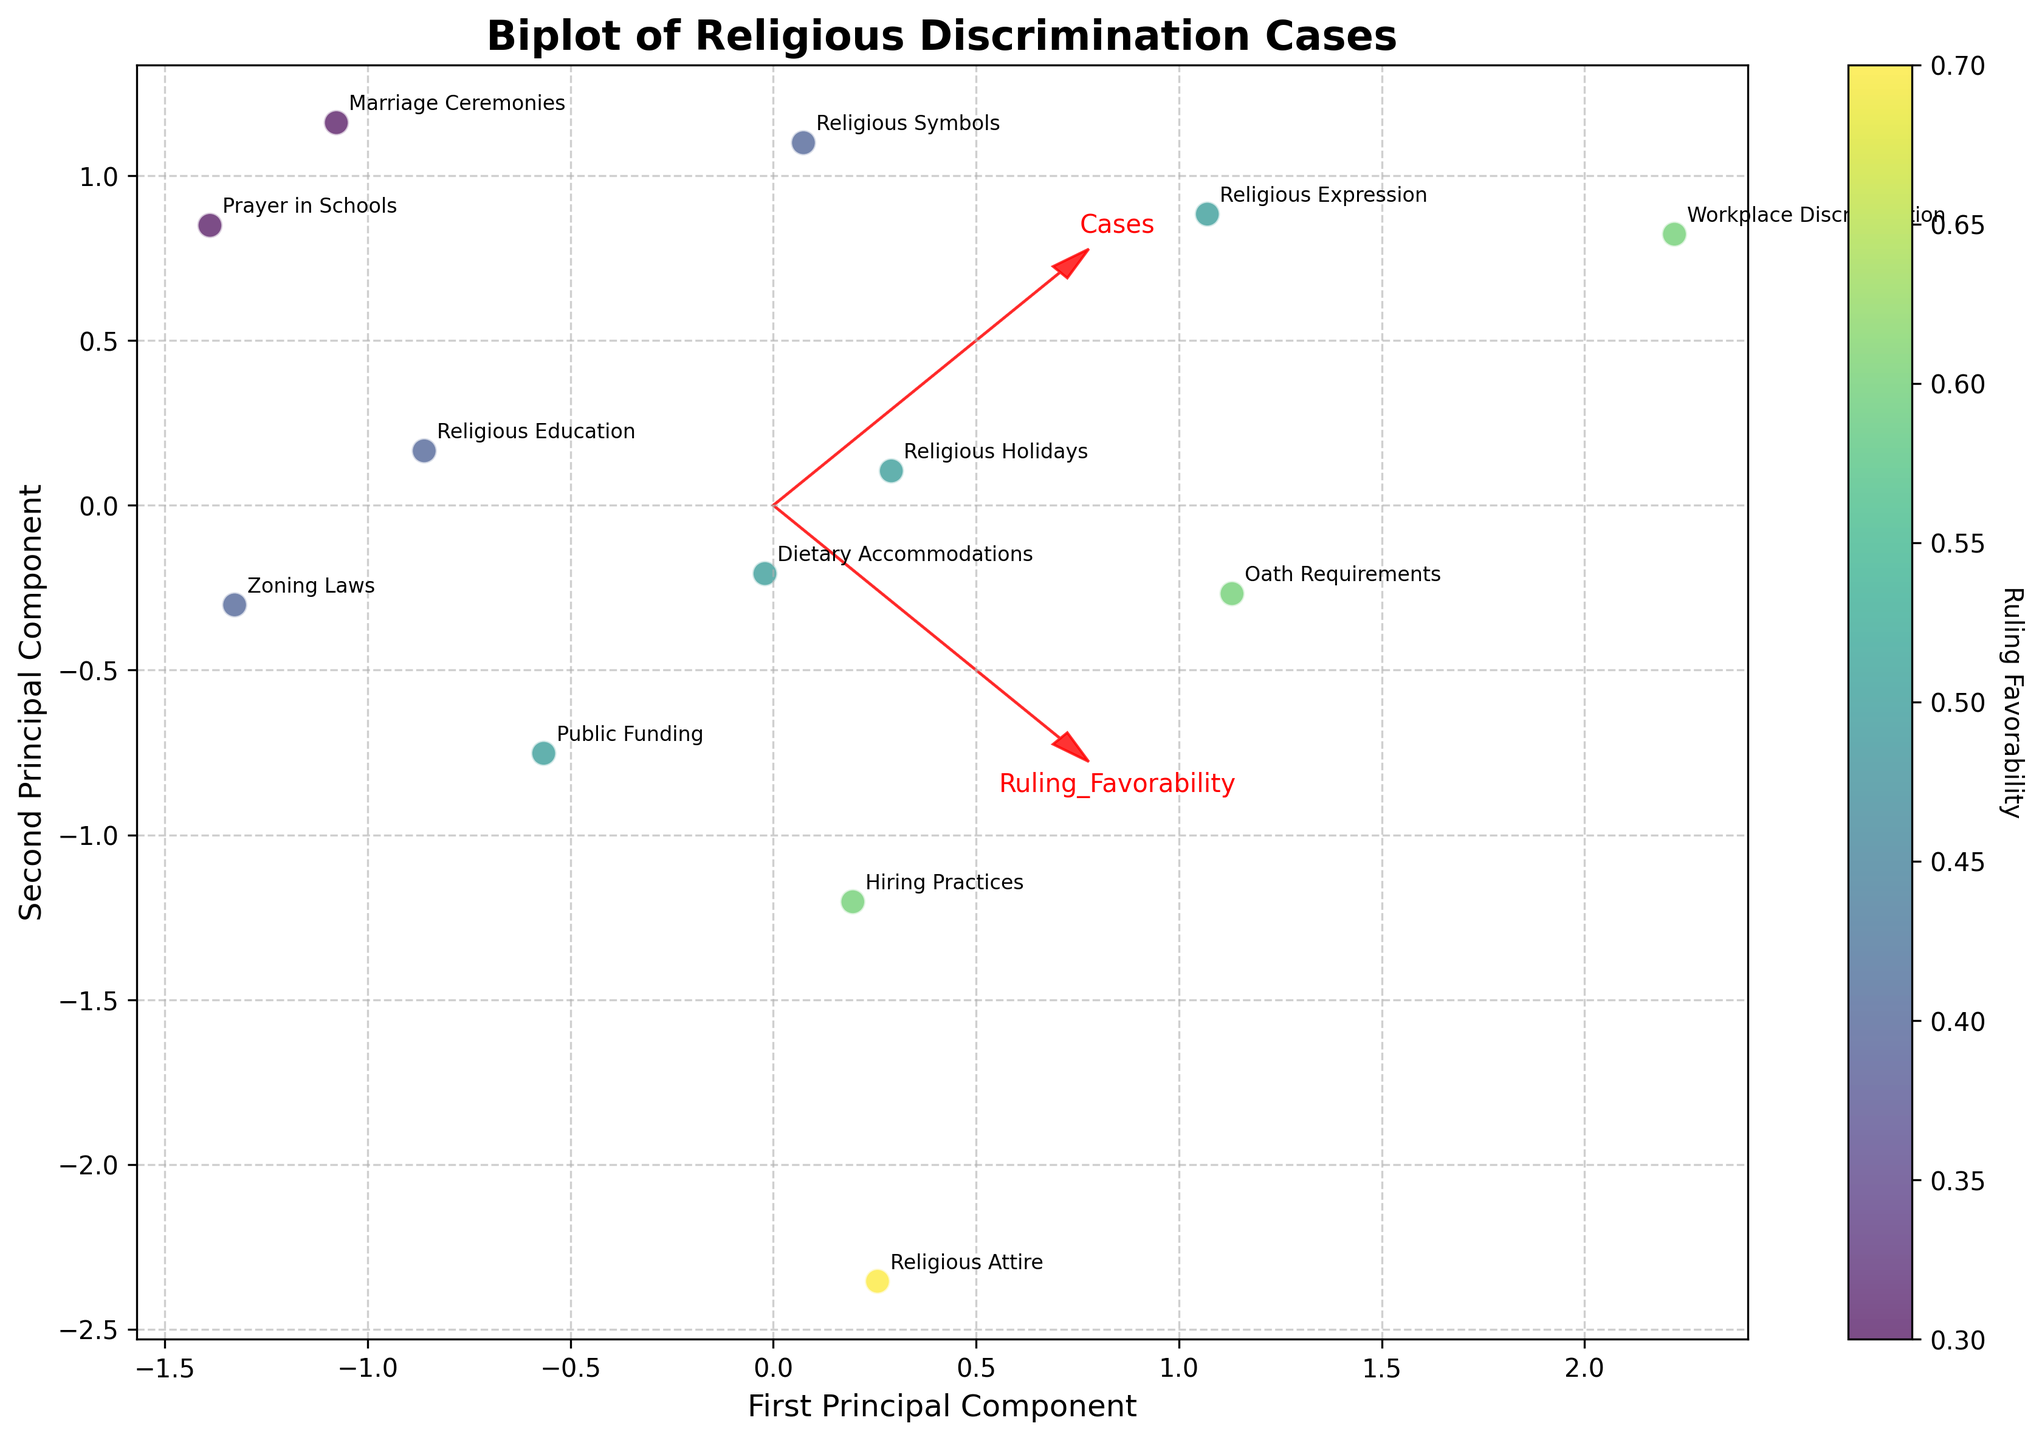What's the title of the plot? The title of the plot is typically displayed at the top and is meant to provide a concise summary of the figure's content.
Answer: Biplot of Religious Discrimination Cases What do the x and y axes represent? The x and y axes usually have labels that define what they represent. In this case, the x-axis is labeled "First Principal Component" and the y-axis is labeled "Second Principal Component".
Answer: First Principal Component and Second Principal Component How many data points are shown in the plot? To determine the number of data points, we count the distinct data points plotted on the figure. Each point corresponds to a legal jurisdiction and court level.
Answer: 13 Which discrimination type has the highest ruling favorability? By examining the color intensity and annotations, we can identify the discrimination type closest to the highest value on the color bar.
Answer: Religious Attire Which jurisdiction shows the highest number of cases? By analyzing the positions of the data points and the annotated discrimination type, we note that "9th Circuit" has 45 cases, the highest in the dataset.
Answer: 9th Circuit How are the variables 'Cases' and 'Ruling_Favorability' represented in the plot? The directions and lengths of the feature vectors (arrows) indicate how each variable is represented in the principal component space. 'Cases' and 'Ruling_Favorability' have arrows pointing in particular directions from the origin.
Answer: By arrows from the origin What is the relationship between 'Cases' and 'Ruling_Favorability'? By examining the alignment of the arrows, we can infer if the trend shows a positive or negative correlation. These two variables have slightly different directions, indicating some correlation but not perfectly aligned.
Answer: Slight positive correlation Which data point is closest to the origin? By looking at the distances from the origin, we identify the point closest to the center of the plot.
Answer: Public Funding (Washington DC Superior Court) Which type of court has the most diverse range of discrimination cases? By examining the distribution and variety of cases represented by different colors and annotations, federal courts show the most diverse cases.
Answer: Federal Courts What does the color of the data points represent? We infer the meaning of the color from the color bar next to the plot. The color represents the 'Ruling Favorability' value.
Answer: Ruling Favorability 